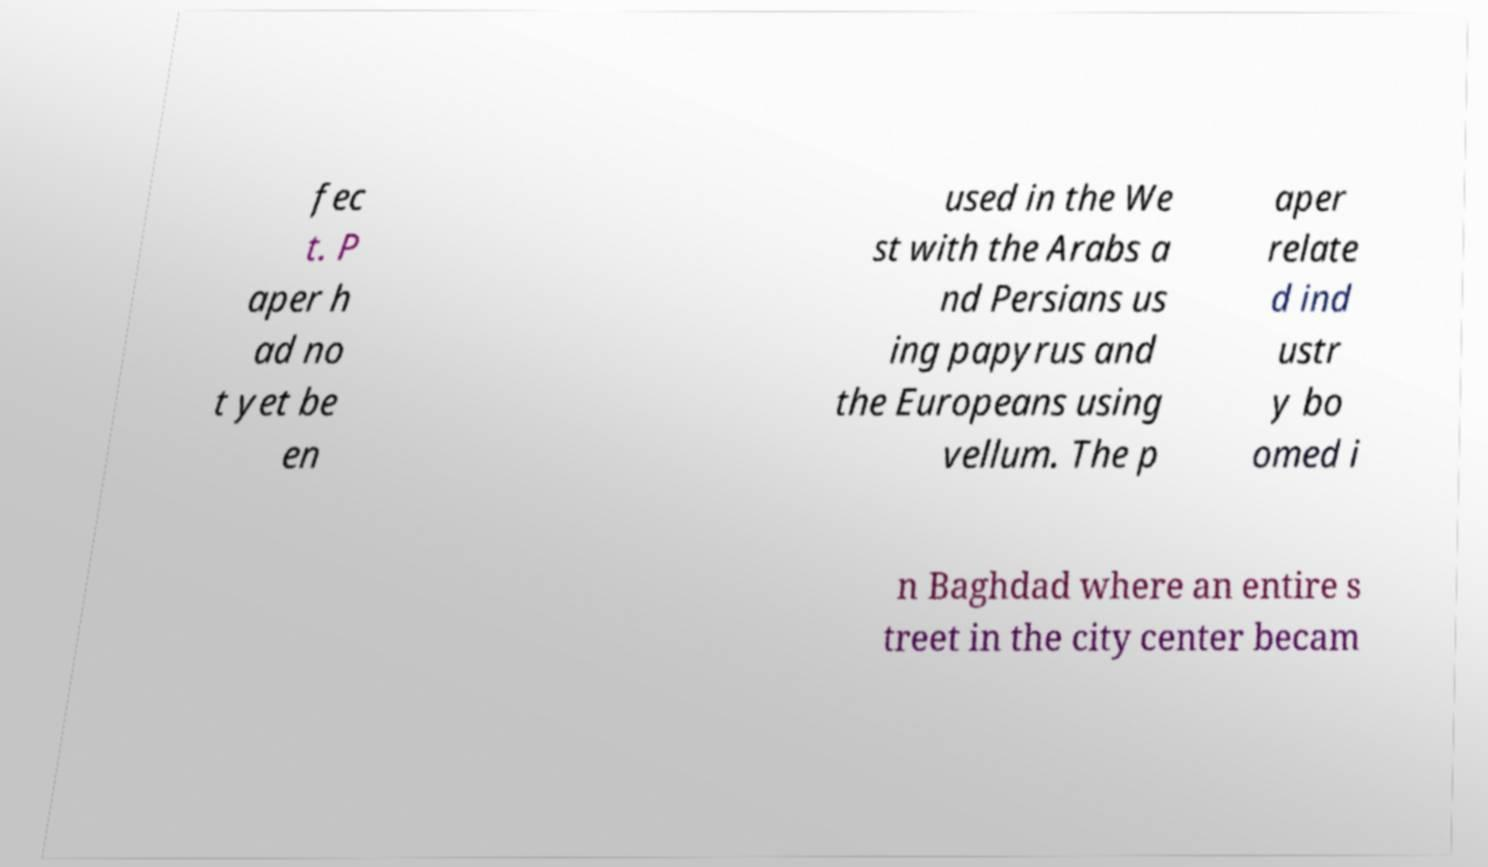I need the written content from this picture converted into text. Can you do that? fec t. P aper h ad no t yet be en used in the We st with the Arabs a nd Persians us ing papyrus and the Europeans using vellum. The p aper relate d ind ustr y bo omed i n Baghdad where an entire s treet in the city center becam 